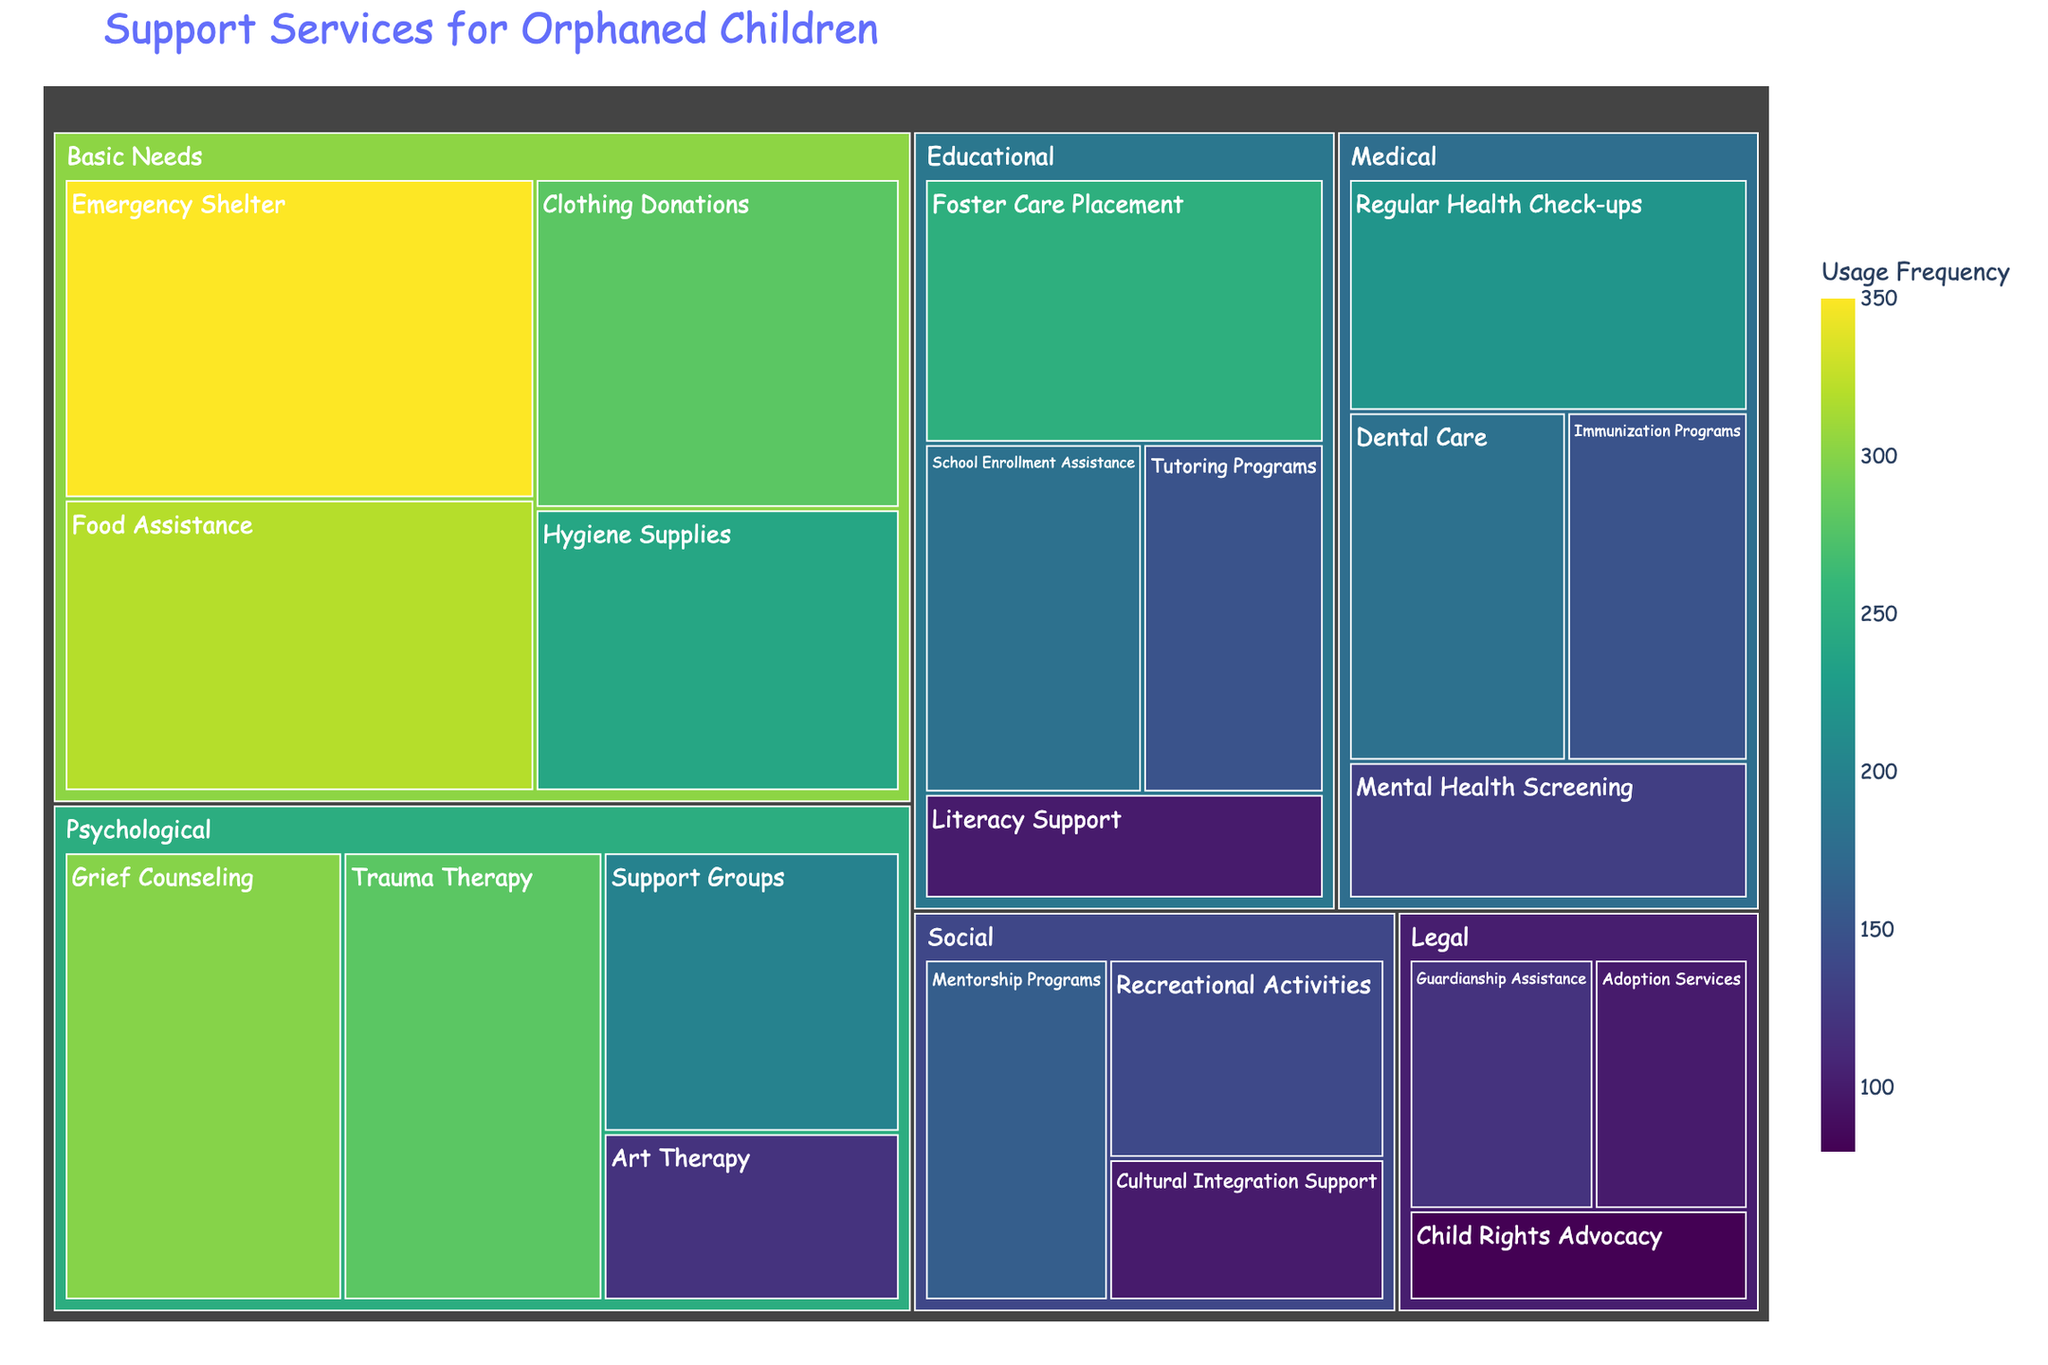What's the title of the figure? The title is usually found at the top of the figure.
Answer: Support Services for Orphaned Children Which service has the highest usage frequency for Basic Needs? Look for the category named Basic Needs and identify the service with the largest section. The Emergency Shelter has the largest section under Basic Needs.
Answer: Emergency Shelter How many services are there in the Educational category? Count the number of unique services listed under Educational. There are four services: Foster Care Placement, School Enrollment Assistance, Tutoring Programs, and Literacy Support.
Answer: 4 What is the difference in usage frequency between Grief Counseling and Trauma Therapy? Locate both services under the Psychological category. Grief Counseling has a value of 300 and Trauma Therapy has a value of 280. Subtract 280 from 300.
Answer: 20 Which category has the highest total usage frequency? Sum the usage frequencies for each category and compare the totals. Basic Needs: 350 + 320 + 280 + 240 = 1190, Psychological: 300 + 280 + 200 + 120 = 900, Educational: 250 + 180 + 150 + 100 = 680, Medical: 220 + 180 + 150 + 130 = 680, Legal: 120 + 100 + 80 = 300, Social: 160 + 140 + 100 = 400. Basic Needs has the highest total.
Answer: Basic Needs How many categories are represented in the figure? Count the number of unique categories listed. The categories are Educational, Psychological, Medical, Basic Needs, Legal, and Social.
Answer: 6 Which service in the Medical category has the lowest usage frequency? Locate the Medical category and identify the service with the smallest section. Mental Health Screening has the lowest value of 130.
Answer: Mental Health Screening What is the combined usage frequency of services in the Social category? Add the usage frequencies of all services under Social. Mentorship Programs: 160, Recreational Activities: 140, Cultural Integration Support: 100. Combined usage frequency is 160 + 140 + 100.
Answer: 400 Which two services have the same usage frequency, and what is that frequency? Look for services with identical section sizes and values. Both Dental Care and School Enrollment Assistance have a usage frequency of 180.
Answer: Dental Care and School Enrollment Assistance, 180 Which category has the smallest total usage frequency and what is it? Sum the usage frequencies for each category as done earlier and find the smallest total. Legal: 300, which is the smallest among the categories.
Answer: Legal, 300 